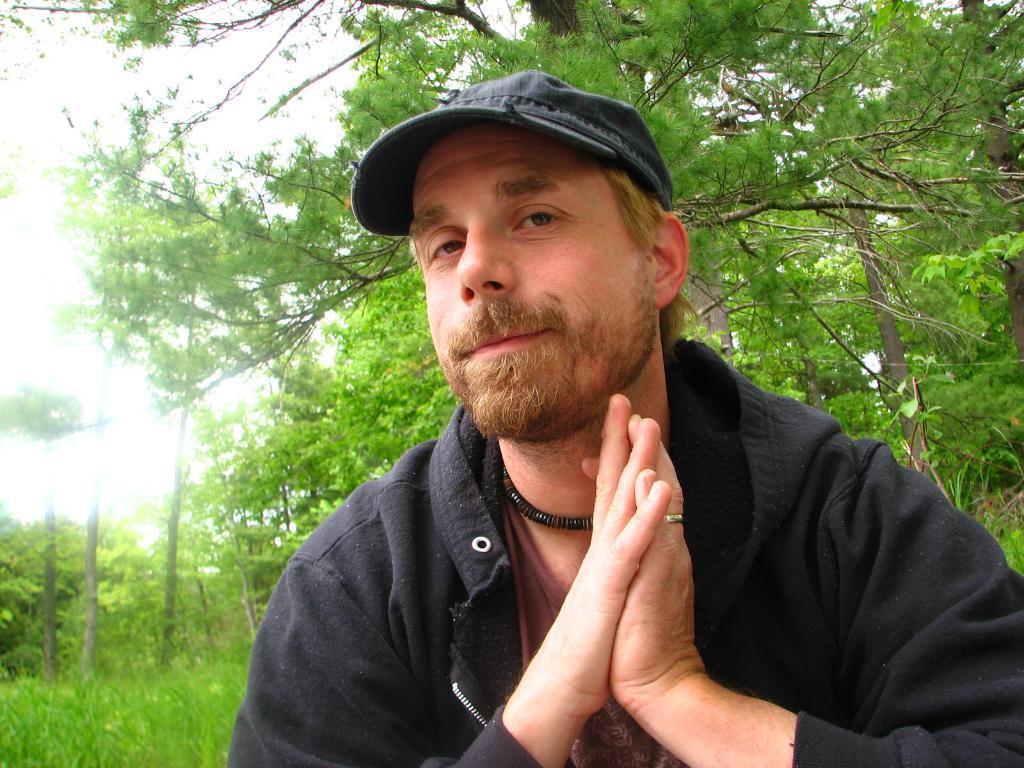Can you describe this image briefly? In front of the picture, we see the man in the black jacket is smiling an he is posing for the photo. He is wearing a black cap. In the background, we see the trees. At the bottom, we see the grass. On the left side, we see the sky. 